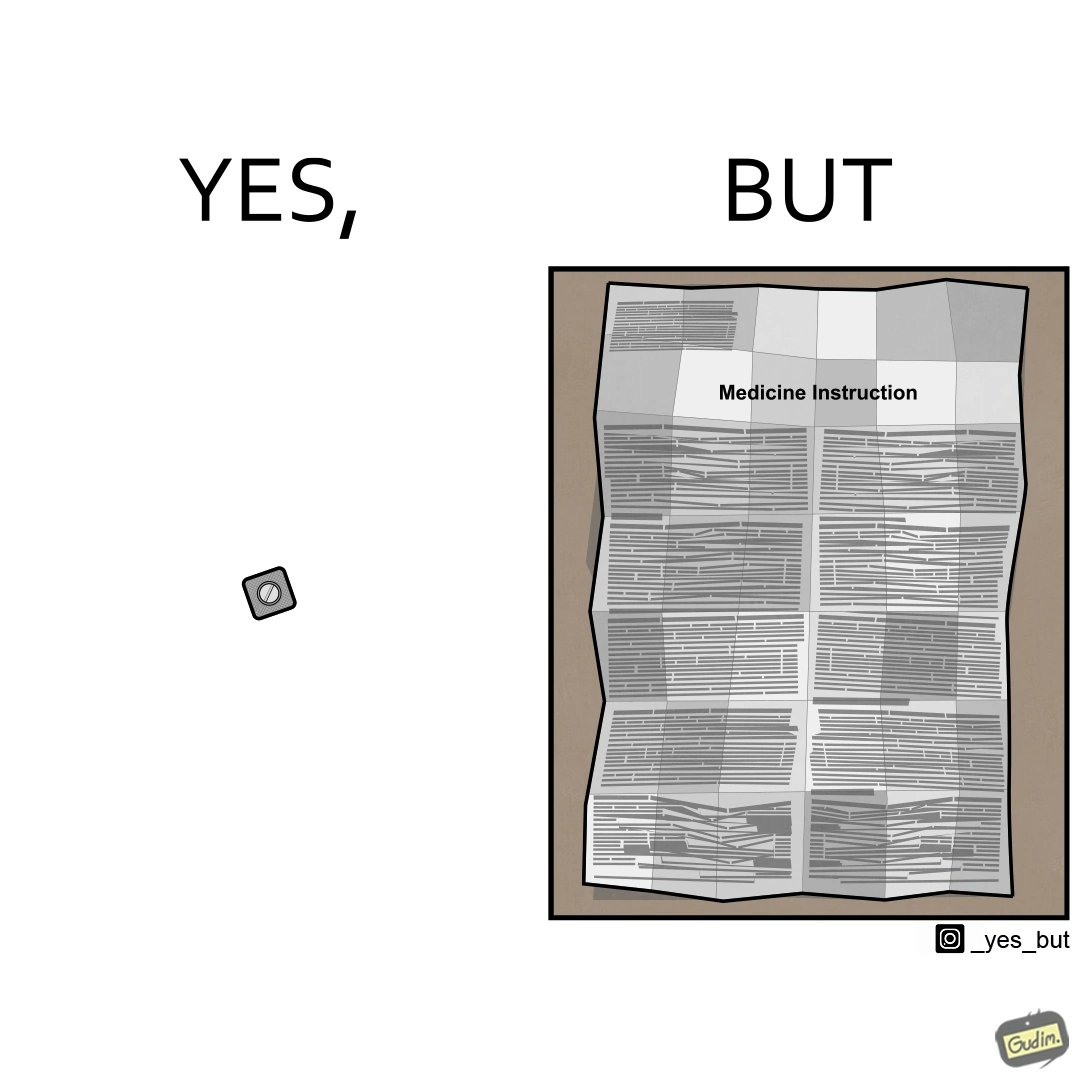Describe the content of this image. the irony in this image is a small thing like a medicine very often has instructions and a manual that is extremely long 